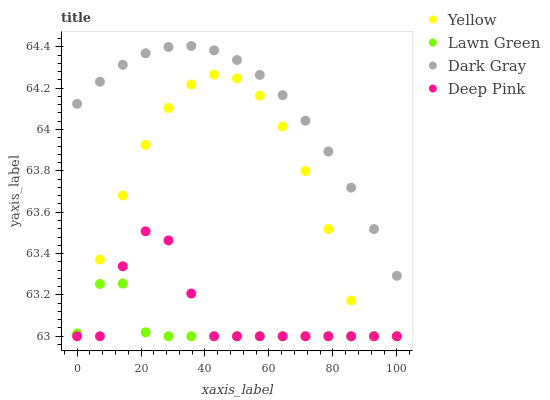Does Lawn Green have the minimum area under the curve?
Answer yes or no. Yes. Does Dark Gray have the maximum area under the curve?
Answer yes or no. Yes. Does Deep Pink have the minimum area under the curve?
Answer yes or no. No. Does Deep Pink have the maximum area under the curve?
Answer yes or no. No. Is Dark Gray the smoothest?
Answer yes or no. Yes. Is Deep Pink the roughest?
Answer yes or no. Yes. Is Lawn Green the smoothest?
Answer yes or no. No. Is Lawn Green the roughest?
Answer yes or no. No. Does Lawn Green have the lowest value?
Answer yes or no. Yes. Does Dark Gray have the highest value?
Answer yes or no. Yes. Does Deep Pink have the highest value?
Answer yes or no. No. Is Yellow less than Dark Gray?
Answer yes or no. Yes. Is Dark Gray greater than Yellow?
Answer yes or no. Yes. Does Yellow intersect Deep Pink?
Answer yes or no. Yes. Is Yellow less than Deep Pink?
Answer yes or no. No. Is Yellow greater than Deep Pink?
Answer yes or no. No. Does Yellow intersect Dark Gray?
Answer yes or no. No. 